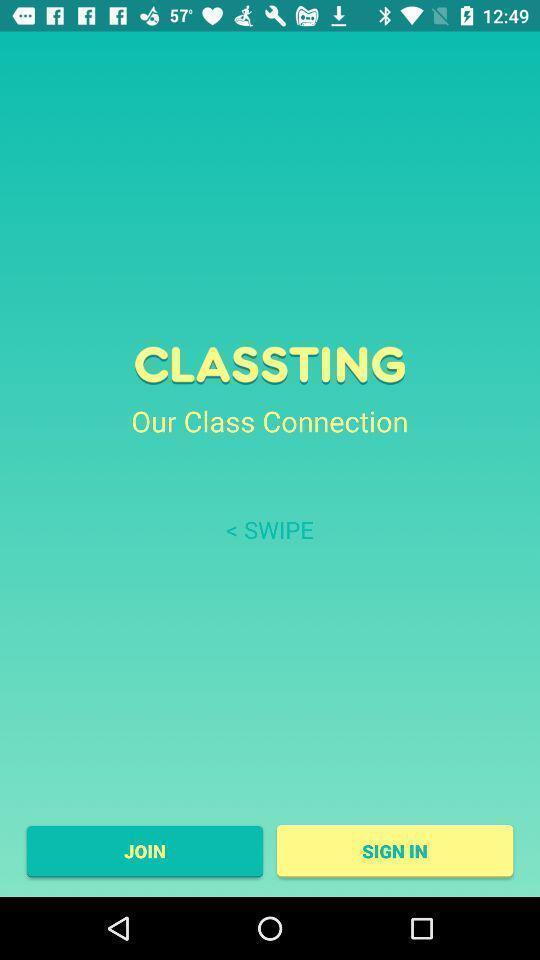Describe this image in words. Sign in page of class connection in a learning app. 